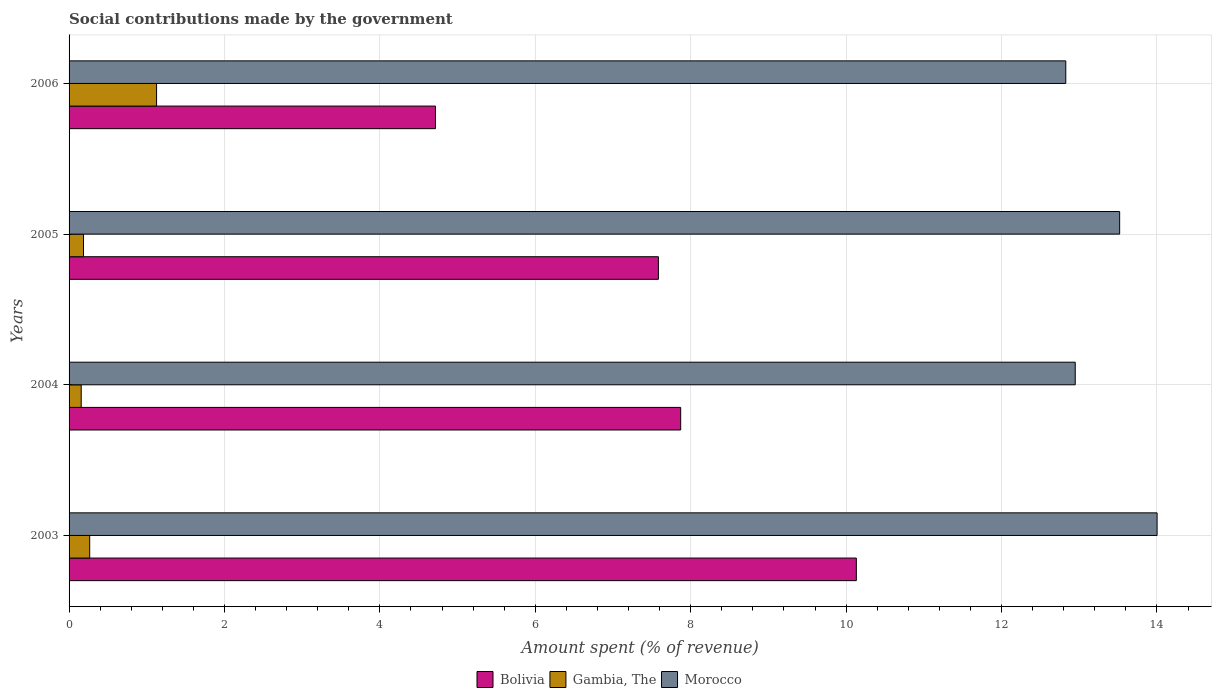Are the number of bars per tick equal to the number of legend labels?
Offer a terse response. Yes. How many bars are there on the 1st tick from the top?
Your answer should be very brief. 3. How many bars are there on the 1st tick from the bottom?
Your response must be concise. 3. What is the label of the 4th group of bars from the top?
Provide a short and direct response. 2003. In how many cases, is the number of bars for a given year not equal to the number of legend labels?
Provide a short and direct response. 0. What is the amount spent (in %) on social contributions in Bolivia in 2004?
Your answer should be compact. 7.87. Across all years, what is the maximum amount spent (in %) on social contributions in Morocco?
Your answer should be very brief. 14. Across all years, what is the minimum amount spent (in %) on social contributions in Morocco?
Provide a succinct answer. 12.83. What is the total amount spent (in %) on social contributions in Morocco in the graph?
Your answer should be very brief. 53.3. What is the difference between the amount spent (in %) on social contributions in Morocco in 2003 and that in 2006?
Your answer should be very brief. 1.18. What is the difference between the amount spent (in %) on social contributions in Gambia, The in 2005 and the amount spent (in %) on social contributions in Bolivia in 2003?
Provide a short and direct response. -9.95. What is the average amount spent (in %) on social contributions in Morocco per year?
Offer a very short reply. 13.32. In the year 2005, what is the difference between the amount spent (in %) on social contributions in Gambia, The and amount spent (in %) on social contributions in Bolivia?
Offer a terse response. -7.4. In how many years, is the amount spent (in %) on social contributions in Gambia, The greater than 4 %?
Your answer should be very brief. 0. What is the ratio of the amount spent (in %) on social contributions in Bolivia in 2004 to that in 2005?
Provide a succinct answer. 1.04. Is the difference between the amount spent (in %) on social contributions in Gambia, The in 2004 and 2005 greater than the difference between the amount spent (in %) on social contributions in Bolivia in 2004 and 2005?
Offer a terse response. No. What is the difference between the highest and the second highest amount spent (in %) on social contributions in Bolivia?
Your response must be concise. 2.26. What is the difference between the highest and the lowest amount spent (in %) on social contributions in Bolivia?
Your answer should be very brief. 5.42. Is the sum of the amount spent (in %) on social contributions in Morocco in 2003 and 2006 greater than the maximum amount spent (in %) on social contributions in Bolivia across all years?
Keep it short and to the point. Yes. What does the 3rd bar from the bottom in 2006 represents?
Give a very brief answer. Morocco. Is it the case that in every year, the sum of the amount spent (in %) on social contributions in Gambia, The and amount spent (in %) on social contributions in Morocco is greater than the amount spent (in %) on social contributions in Bolivia?
Give a very brief answer. Yes. Are all the bars in the graph horizontal?
Provide a short and direct response. Yes. How many years are there in the graph?
Make the answer very short. 4. Are the values on the major ticks of X-axis written in scientific E-notation?
Make the answer very short. No. Does the graph contain grids?
Your response must be concise. Yes. What is the title of the graph?
Make the answer very short. Social contributions made by the government. What is the label or title of the X-axis?
Provide a short and direct response. Amount spent (% of revenue). What is the Amount spent (% of revenue) of Bolivia in 2003?
Provide a short and direct response. 10.13. What is the Amount spent (% of revenue) of Gambia, The in 2003?
Give a very brief answer. 0.27. What is the Amount spent (% of revenue) in Morocco in 2003?
Offer a terse response. 14. What is the Amount spent (% of revenue) in Bolivia in 2004?
Offer a terse response. 7.87. What is the Amount spent (% of revenue) of Gambia, The in 2004?
Provide a short and direct response. 0.16. What is the Amount spent (% of revenue) in Morocco in 2004?
Offer a terse response. 12.95. What is the Amount spent (% of revenue) of Bolivia in 2005?
Your answer should be very brief. 7.58. What is the Amount spent (% of revenue) of Gambia, The in 2005?
Offer a very short reply. 0.19. What is the Amount spent (% of revenue) in Morocco in 2005?
Provide a short and direct response. 13.52. What is the Amount spent (% of revenue) of Bolivia in 2006?
Ensure brevity in your answer.  4.72. What is the Amount spent (% of revenue) of Gambia, The in 2006?
Provide a succinct answer. 1.13. What is the Amount spent (% of revenue) of Morocco in 2006?
Offer a terse response. 12.83. Across all years, what is the maximum Amount spent (% of revenue) in Bolivia?
Keep it short and to the point. 10.13. Across all years, what is the maximum Amount spent (% of revenue) of Gambia, The?
Give a very brief answer. 1.13. Across all years, what is the maximum Amount spent (% of revenue) in Morocco?
Keep it short and to the point. 14. Across all years, what is the minimum Amount spent (% of revenue) in Bolivia?
Keep it short and to the point. 4.72. Across all years, what is the minimum Amount spent (% of revenue) in Gambia, The?
Offer a terse response. 0.16. Across all years, what is the minimum Amount spent (% of revenue) of Morocco?
Keep it short and to the point. 12.83. What is the total Amount spent (% of revenue) in Bolivia in the graph?
Your answer should be compact. 30.3. What is the total Amount spent (% of revenue) of Gambia, The in the graph?
Offer a terse response. 1.73. What is the total Amount spent (% of revenue) in Morocco in the graph?
Provide a succinct answer. 53.3. What is the difference between the Amount spent (% of revenue) in Bolivia in 2003 and that in 2004?
Ensure brevity in your answer.  2.26. What is the difference between the Amount spent (% of revenue) in Gambia, The in 2003 and that in 2004?
Provide a short and direct response. 0.11. What is the difference between the Amount spent (% of revenue) of Morocco in 2003 and that in 2004?
Your answer should be compact. 1.05. What is the difference between the Amount spent (% of revenue) of Bolivia in 2003 and that in 2005?
Provide a short and direct response. 2.55. What is the difference between the Amount spent (% of revenue) in Gambia, The in 2003 and that in 2005?
Offer a very short reply. 0.08. What is the difference between the Amount spent (% of revenue) in Morocco in 2003 and that in 2005?
Ensure brevity in your answer.  0.48. What is the difference between the Amount spent (% of revenue) in Bolivia in 2003 and that in 2006?
Your answer should be very brief. 5.42. What is the difference between the Amount spent (% of revenue) in Gambia, The in 2003 and that in 2006?
Offer a very short reply. -0.86. What is the difference between the Amount spent (% of revenue) in Morocco in 2003 and that in 2006?
Ensure brevity in your answer.  1.18. What is the difference between the Amount spent (% of revenue) in Bolivia in 2004 and that in 2005?
Your answer should be compact. 0.29. What is the difference between the Amount spent (% of revenue) of Gambia, The in 2004 and that in 2005?
Give a very brief answer. -0.03. What is the difference between the Amount spent (% of revenue) of Morocco in 2004 and that in 2005?
Offer a very short reply. -0.57. What is the difference between the Amount spent (% of revenue) in Bolivia in 2004 and that in 2006?
Provide a succinct answer. 3.16. What is the difference between the Amount spent (% of revenue) of Gambia, The in 2004 and that in 2006?
Your answer should be compact. -0.97. What is the difference between the Amount spent (% of revenue) of Morocco in 2004 and that in 2006?
Your response must be concise. 0.12. What is the difference between the Amount spent (% of revenue) in Bolivia in 2005 and that in 2006?
Your response must be concise. 2.87. What is the difference between the Amount spent (% of revenue) of Gambia, The in 2005 and that in 2006?
Make the answer very short. -0.94. What is the difference between the Amount spent (% of revenue) of Morocco in 2005 and that in 2006?
Provide a succinct answer. 0.69. What is the difference between the Amount spent (% of revenue) in Bolivia in 2003 and the Amount spent (% of revenue) in Gambia, The in 2004?
Offer a terse response. 9.98. What is the difference between the Amount spent (% of revenue) in Bolivia in 2003 and the Amount spent (% of revenue) in Morocco in 2004?
Your response must be concise. -2.82. What is the difference between the Amount spent (% of revenue) in Gambia, The in 2003 and the Amount spent (% of revenue) in Morocco in 2004?
Provide a succinct answer. -12.68. What is the difference between the Amount spent (% of revenue) of Bolivia in 2003 and the Amount spent (% of revenue) of Gambia, The in 2005?
Your response must be concise. 9.95. What is the difference between the Amount spent (% of revenue) of Bolivia in 2003 and the Amount spent (% of revenue) of Morocco in 2005?
Provide a succinct answer. -3.39. What is the difference between the Amount spent (% of revenue) in Gambia, The in 2003 and the Amount spent (% of revenue) in Morocco in 2005?
Ensure brevity in your answer.  -13.25. What is the difference between the Amount spent (% of revenue) of Bolivia in 2003 and the Amount spent (% of revenue) of Gambia, The in 2006?
Provide a succinct answer. 9.01. What is the difference between the Amount spent (% of revenue) in Bolivia in 2003 and the Amount spent (% of revenue) in Morocco in 2006?
Your answer should be very brief. -2.7. What is the difference between the Amount spent (% of revenue) of Gambia, The in 2003 and the Amount spent (% of revenue) of Morocco in 2006?
Offer a very short reply. -12.56. What is the difference between the Amount spent (% of revenue) in Bolivia in 2004 and the Amount spent (% of revenue) in Gambia, The in 2005?
Ensure brevity in your answer.  7.69. What is the difference between the Amount spent (% of revenue) of Bolivia in 2004 and the Amount spent (% of revenue) of Morocco in 2005?
Provide a succinct answer. -5.65. What is the difference between the Amount spent (% of revenue) in Gambia, The in 2004 and the Amount spent (% of revenue) in Morocco in 2005?
Your response must be concise. -13.36. What is the difference between the Amount spent (% of revenue) of Bolivia in 2004 and the Amount spent (% of revenue) of Gambia, The in 2006?
Provide a succinct answer. 6.74. What is the difference between the Amount spent (% of revenue) of Bolivia in 2004 and the Amount spent (% of revenue) of Morocco in 2006?
Make the answer very short. -4.96. What is the difference between the Amount spent (% of revenue) of Gambia, The in 2004 and the Amount spent (% of revenue) of Morocco in 2006?
Keep it short and to the point. -12.67. What is the difference between the Amount spent (% of revenue) in Bolivia in 2005 and the Amount spent (% of revenue) in Gambia, The in 2006?
Offer a very short reply. 6.46. What is the difference between the Amount spent (% of revenue) in Bolivia in 2005 and the Amount spent (% of revenue) in Morocco in 2006?
Keep it short and to the point. -5.24. What is the difference between the Amount spent (% of revenue) in Gambia, The in 2005 and the Amount spent (% of revenue) in Morocco in 2006?
Make the answer very short. -12.64. What is the average Amount spent (% of revenue) of Bolivia per year?
Provide a short and direct response. 7.58. What is the average Amount spent (% of revenue) in Gambia, The per year?
Your answer should be compact. 0.43. What is the average Amount spent (% of revenue) in Morocco per year?
Your answer should be compact. 13.32. In the year 2003, what is the difference between the Amount spent (% of revenue) in Bolivia and Amount spent (% of revenue) in Gambia, The?
Your answer should be very brief. 9.87. In the year 2003, what is the difference between the Amount spent (% of revenue) in Bolivia and Amount spent (% of revenue) in Morocco?
Make the answer very short. -3.87. In the year 2003, what is the difference between the Amount spent (% of revenue) in Gambia, The and Amount spent (% of revenue) in Morocco?
Make the answer very short. -13.74. In the year 2004, what is the difference between the Amount spent (% of revenue) in Bolivia and Amount spent (% of revenue) in Gambia, The?
Your answer should be compact. 7.71. In the year 2004, what is the difference between the Amount spent (% of revenue) in Bolivia and Amount spent (% of revenue) in Morocco?
Your answer should be compact. -5.08. In the year 2004, what is the difference between the Amount spent (% of revenue) in Gambia, The and Amount spent (% of revenue) in Morocco?
Provide a short and direct response. -12.79. In the year 2005, what is the difference between the Amount spent (% of revenue) of Bolivia and Amount spent (% of revenue) of Gambia, The?
Provide a succinct answer. 7.4. In the year 2005, what is the difference between the Amount spent (% of revenue) in Bolivia and Amount spent (% of revenue) in Morocco?
Provide a succinct answer. -5.94. In the year 2005, what is the difference between the Amount spent (% of revenue) in Gambia, The and Amount spent (% of revenue) in Morocco?
Provide a short and direct response. -13.33. In the year 2006, what is the difference between the Amount spent (% of revenue) in Bolivia and Amount spent (% of revenue) in Gambia, The?
Give a very brief answer. 3.59. In the year 2006, what is the difference between the Amount spent (% of revenue) of Bolivia and Amount spent (% of revenue) of Morocco?
Offer a terse response. -8.11. In the year 2006, what is the difference between the Amount spent (% of revenue) in Gambia, The and Amount spent (% of revenue) in Morocco?
Keep it short and to the point. -11.7. What is the ratio of the Amount spent (% of revenue) of Bolivia in 2003 to that in 2004?
Ensure brevity in your answer.  1.29. What is the ratio of the Amount spent (% of revenue) in Gambia, The in 2003 to that in 2004?
Give a very brief answer. 1.7. What is the ratio of the Amount spent (% of revenue) in Morocco in 2003 to that in 2004?
Offer a very short reply. 1.08. What is the ratio of the Amount spent (% of revenue) of Bolivia in 2003 to that in 2005?
Give a very brief answer. 1.34. What is the ratio of the Amount spent (% of revenue) in Gambia, The in 2003 to that in 2005?
Give a very brief answer. 1.43. What is the ratio of the Amount spent (% of revenue) in Morocco in 2003 to that in 2005?
Keep it short and to the point. 1.04. What is the ratio of the Amount spent (% of revenue) in Bolivia in 2003 to that in 2006?
Your answer should be very brief. 2.15. What is the ratio of the Amount spent (% of revenue) in Gambia, The in 2003 to that in 2006?
Give a very brief answer. 0.24. What is the ratio of the Amount spent (% of revenue) in Morocco in 2003 to that in 2006?
Ensure brevity in your answer.  1.09. What is the ratio of the Amount spent (% of revenue) of Bolivia in 2004 to that in 2005?
Keep it short and to the point. 1.04. What is the ratio of the Amount spent (% of revenue) in Gambia, The in 2004 to that in 2005?
Keep it short and to the point. 0.84. What is the ratio of the Amount spent (% of revenue) of Morocco in 2004 to that in 2005?
Keep it short and to the point. 0.96. What is the ratio of the Amount spent (% of revenue) in Bolivia in 2004 to that in 2006?
Your answer should be very brief. 1.67. What is the ratio of the Amount spent (% of revenue) in Gambia, The in 2004 to that in 2006?
Keep it short and to the point. 0.14. What is the ratio of the Amount spent (% of revenue) in Morocco in 2004 to that in 2006?
Your answer should be very brief. 1.01. What is the ratio of the Amount spent (% of revenue) in Bolivia in 2005 to that in 2006?
Offer a very short reply. 1.61. What is the ratio of the Amount spent (% of revenue) of Gambia, The in 2005 to that in 2006?
Provide a short and direct response. 0.17. What is the ratio of the Amount spent (% of revenue) of Morocco in 2005 to that in 2006?
Provide a short and direct response. 1.05. What is the difference between the highest and the second highest Amount spent (% of revenue) of Bolivia?
Your answer should be very brief. 2.26. What is the difference between the highest and the second highest Amount spent (% of revenue) of Gambia, The?
Offer a terse response. 0.86. What is the difference between the highest and the second highest Amount spent (% of revenue) of Morocco?
Provide a short and direct response. 0.48. What is the difference between the highest and the lowest Amount spent (% of revenue) in Bolivia?
Give a very brief answer. 5.42. What is the difference between the highest and the lowest Amount spent (% of revenue) in Gambia, The?
Keep it short and to the point. 0.97. What is the difference between the highest and the lowest Amount spent (% of revenue) in Morocco?
Give a very brief answer. 1.18. 